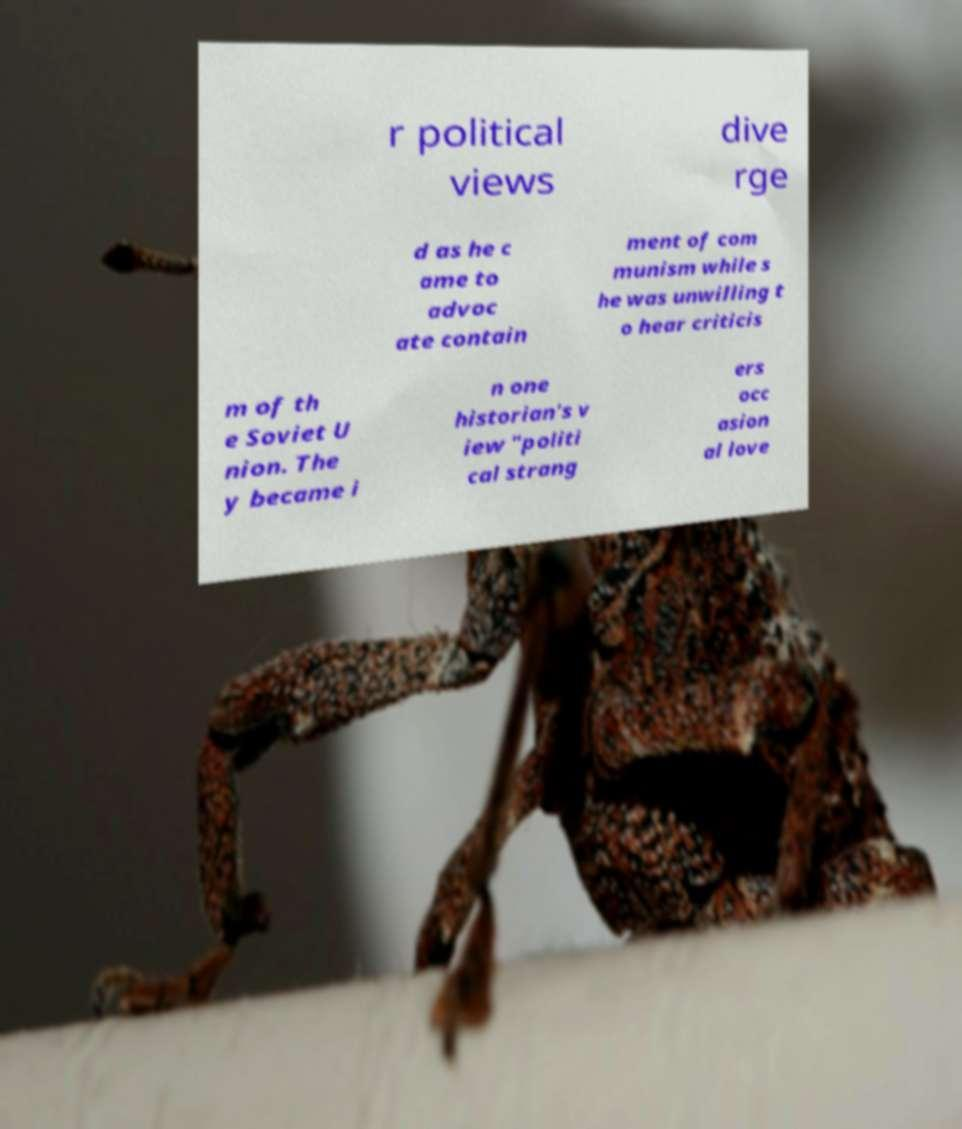For documentation purposes, I need the text within this image transcribed. Could you provide that? r political views dive rge d as he c ame to advoc ate contain ment of com munism while s he was unwilling t o hear criticis m of th e Soviet U nion. The y became i n one historian's v iew "politi cal strang ers occ asion al love 